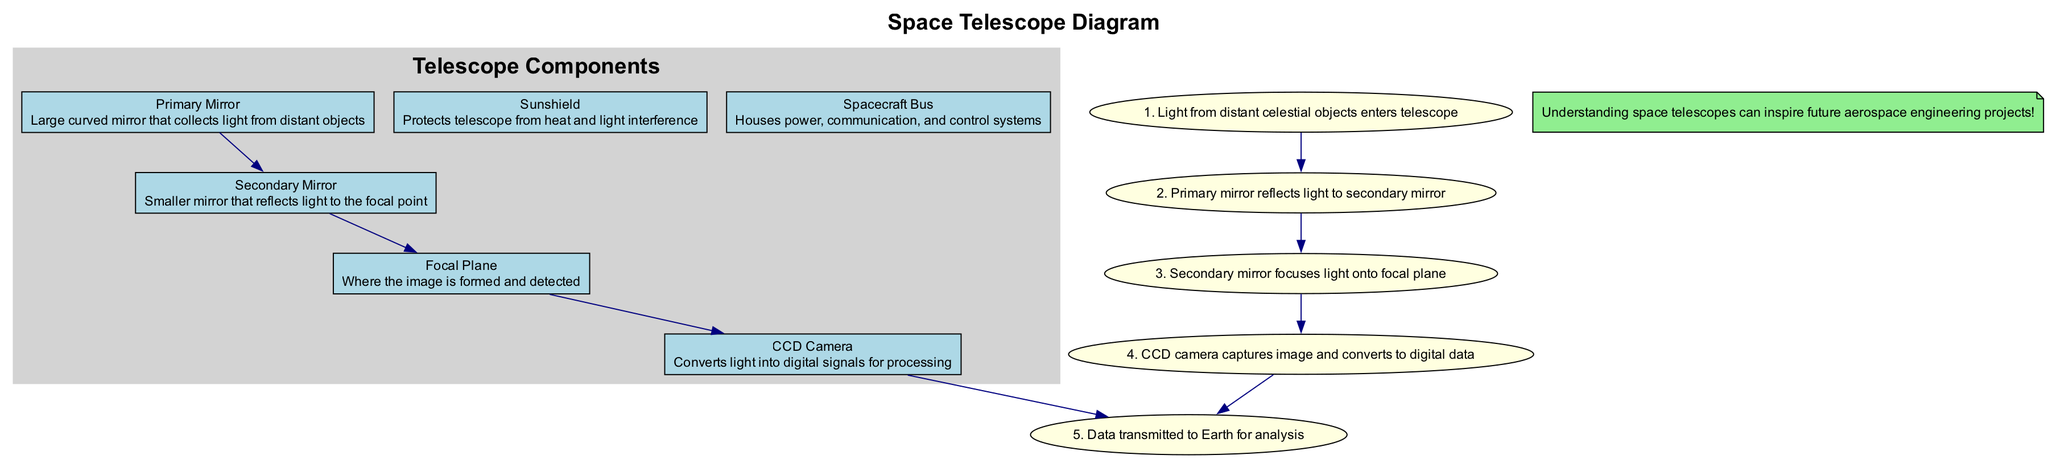What is the primary function of the Primary Mirror? The Primary Mirror is a large curved mirror that collects light from distant celestial objects, allowing it to gather enough light for observations.
Answer: Collects light How many components are labeled in the diagram? The diagram includes six labeled components: Primary Mirror, Secondary Mirror, Focal Plane, CCD Camera, Sunshield, and Spacecraft Bus.
Answer: Six What step follows after the Secondary Mirror in the light capturing process? After the Secondary Mirror reflects light, the next step is focusing the light onto the Focal Plane, where the image is formed and detected.
Answer: Focal Plane Which component protects the telescope from heat and light interference? The Sunshield is specifically designed to protect the telescope from external heat and light, enabling it to maintain optimal conditions for observing distant celestial objects.
Answer: Sunshield What is the first step in the light capturing process? The process begins with light from distant celestial objects entering the telescope, marking the start of the observation sequence.
Answer: Light enters telescope How does the CCD Camera contribute to the observation? The CCD Camera converts the captured light into digital signals, which are essential for processing and analyzing the images of celestial objects.
Answer: Converts to digital signals What is the relationship between the Primary Mirror and the Secondary Mirror? The Primary Mirror reflects the collected light towards the Secondary Mirror, which further directs the light to the Focal Plane, establishing a critical optical pathway in the telescope's operation.
Answer: Reflects light What role does the Spacecraft Bus play in the telescope's operation? The Spacecraft Bus houses the power, communication, and control systems necessary for the telescope's operation, facilitating its overall functionality and effectiveness in space observation.
Answer: Houses power and systems 